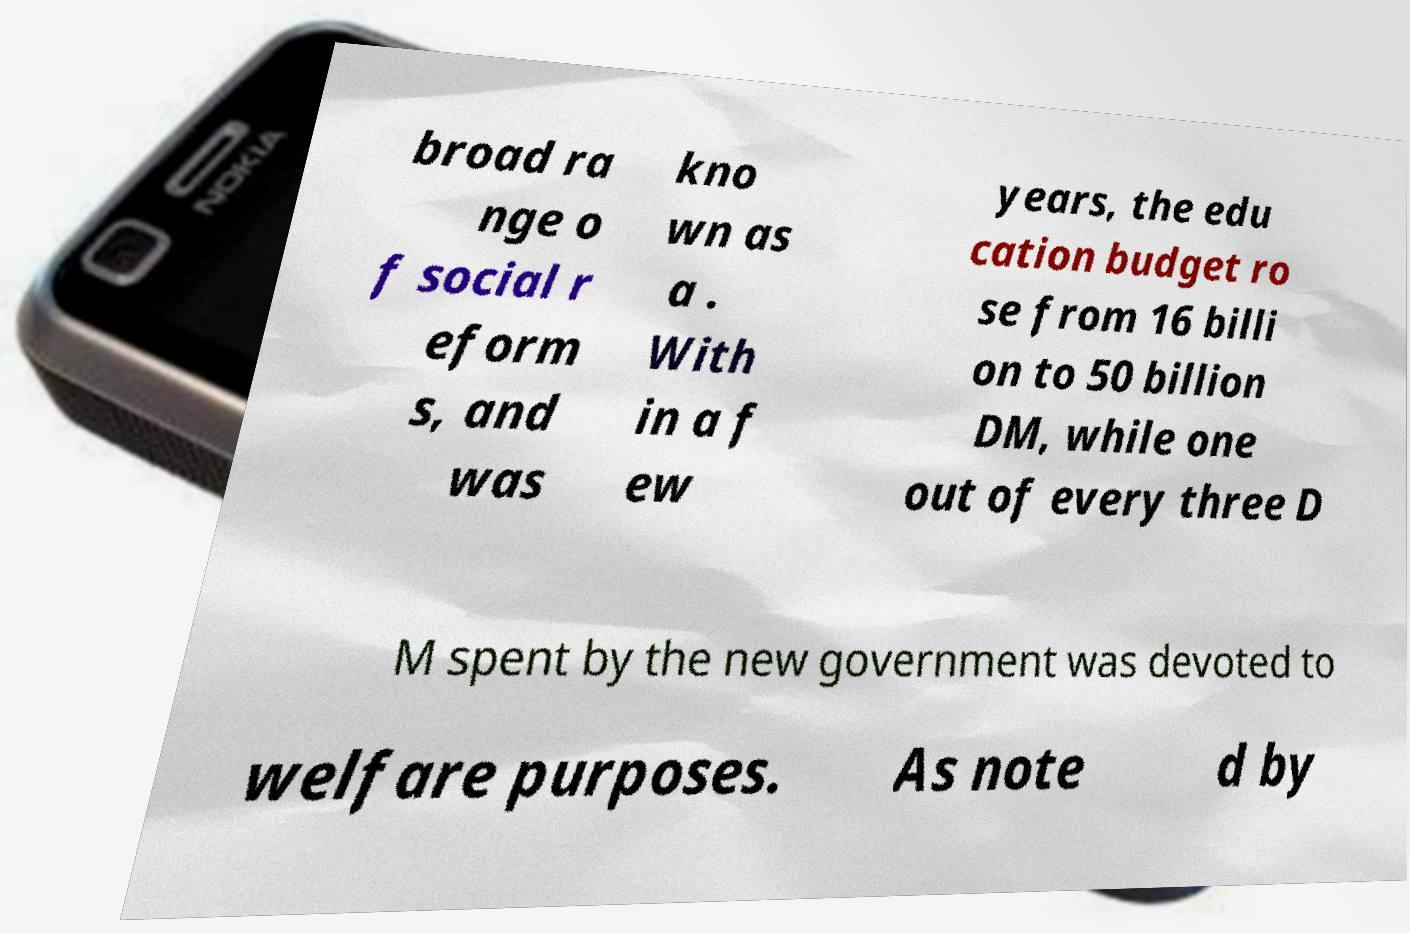Can you read and provide the text displayed in the image?This photo seems to have some interesting text. Can you extract and type it out for me? broad ra nge o f social r eform s, and was kno wn as a . With in a f ew years, the edu cation budget ro se from 16 billi on to 50 billion DM, while one out of every three D M spent by the new government was devoted to welfare purposes. As note d by 